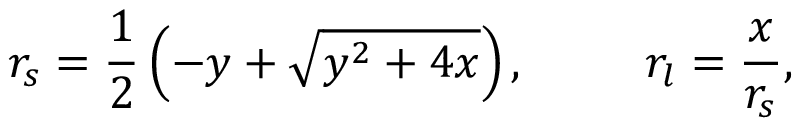Convert formula to latex. <formula><loc_0><loc_0><loc_500><loc_500>r _ { s } = \frac { 1 } { 2 } \left ( - y + \sqrt { y ^ { 2 } + 4 x } \right ) , \, r _ { l } = \frac { x } { r _ { s } } ,</formula> 